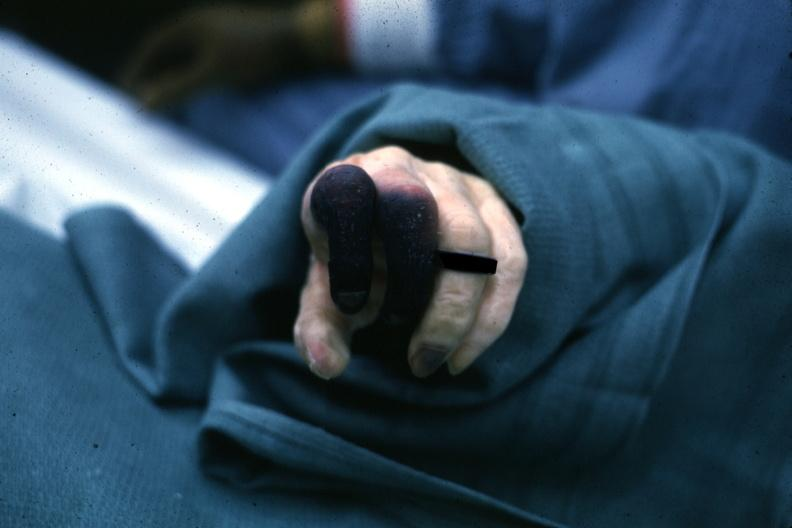what does this image show?
Answer the question using a single word or phrase. Well shown gangrene fingers 